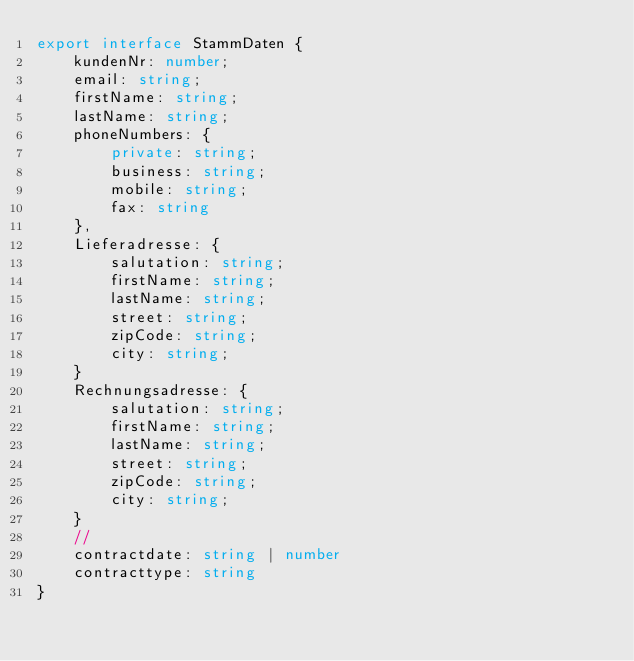<code> <loc_0><loc_0><loc_500><loc_500><_TypeScript_>export interface StammDaten {
    kundenNr: number;
    email: string;
    firstName: string;
    lastName: string;
    phoneNumbers: {
        private: string;
        business: string;
        mobile: string;
        fax: string
    },
    Lieferadresse: {
        salutation: string;
        firstName: string;
        lastName: string;
        street: string;
        zipCode: string;
        city: string;
    }
    Rechnungsadresse: {
        salutation: string;
        firstName: string;
        lastName: string;
        street: string;
        zipCode: string;
        city: string;
    }
    //
    contractdate: string | number
    contracttype: string
}
</code> 